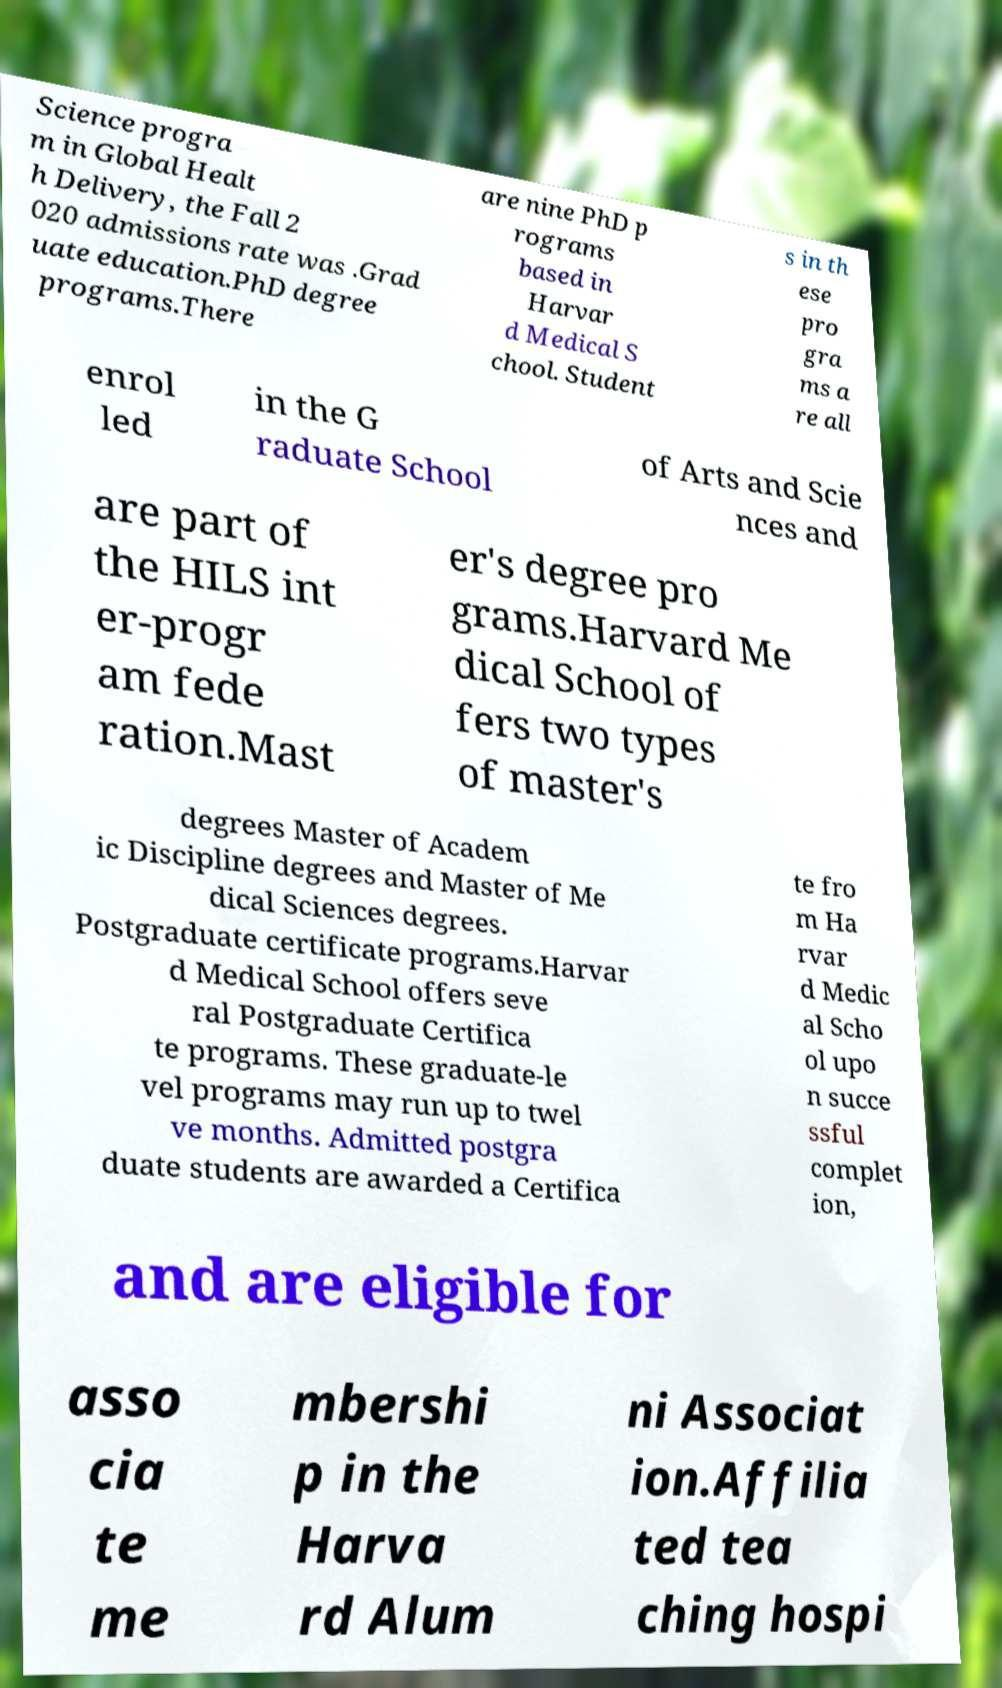There's text embedded in this image that I need extracted. Can you transcribe it verbatim? Science progra m in Global Healt h Delivery, the Fall 2 020 admissions rate was .Grad uate education.PhD degree programs.There are nine PhD p rograms based in Harvar d Medical S chool. Student s in th ese pro gra ms a re all enrol led in the G raduate School of Arts and Scie nces and are part of the HILS int er-progr am fede ration.Mast er's degree pro grams.Harvard Me dical School of fers two types of master's degrees Master of Academ ic Discipline degrees and Master of Me dical Sciences degrees. Postgraduate certificate programs.Harvar d Medical School offers seve ral Postgraduate Certifica te programs. These graduate-le vel programs may run up to twel ve months. Admitted postgra duate students are awarded a Certifica te fro m Ha rvar d Medic al Scho ol upo n succe ssful complet ion, and are eligible for asso cia te me mbershi p in the Harva rd Alum ni Associat ion.Affilia ted tea ching hospi 